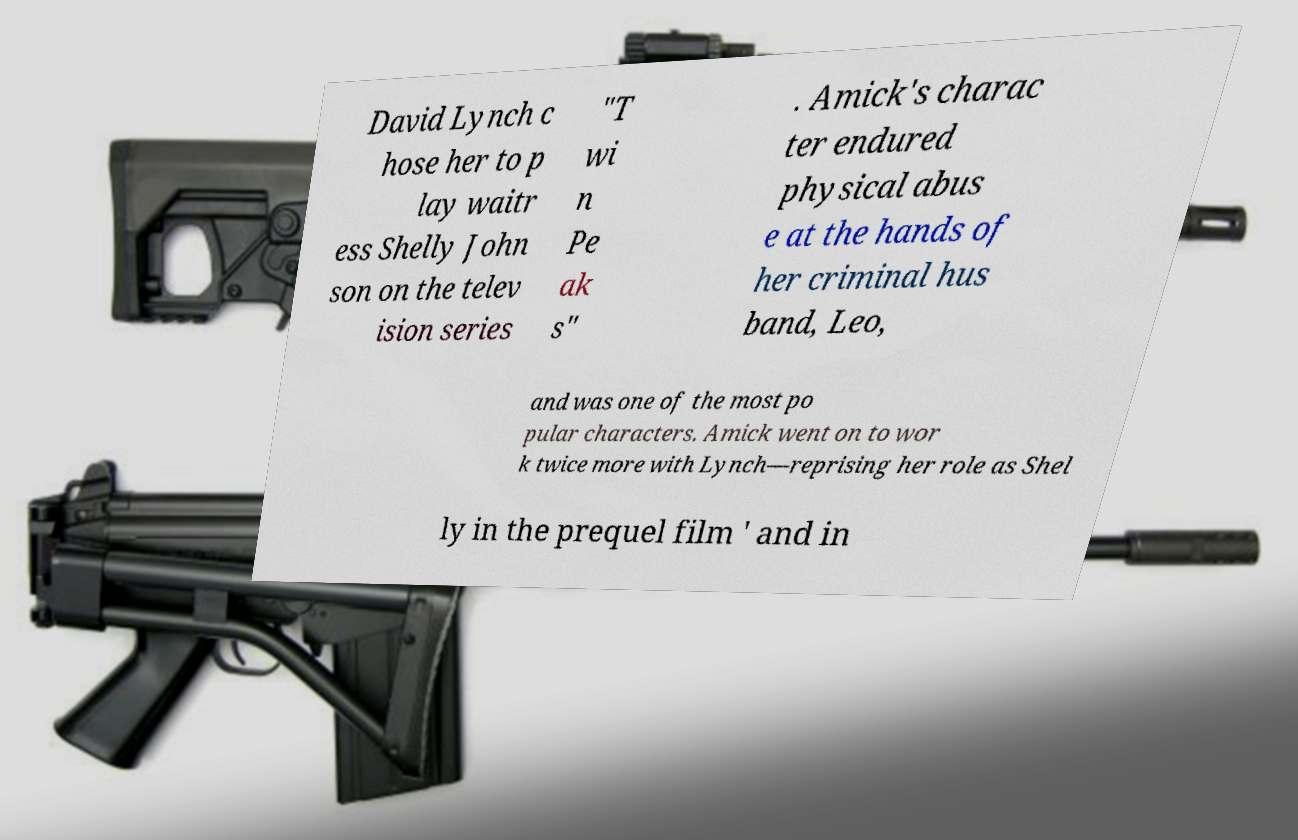Could you assist in decoding the text presented in this image and type it out clearly? David Lynch c hose her to p lay waitr ess Shelly John son on the telev ision series "T wi n Pe ak s" . Amick's charac ter endured physical abus e at the hands of her criminal hus band, Leo, and was one of the most po pular characters. Amick went on to wor k twice more with Lynch—reprising her role as Shel ly in the prequel film ' and in 